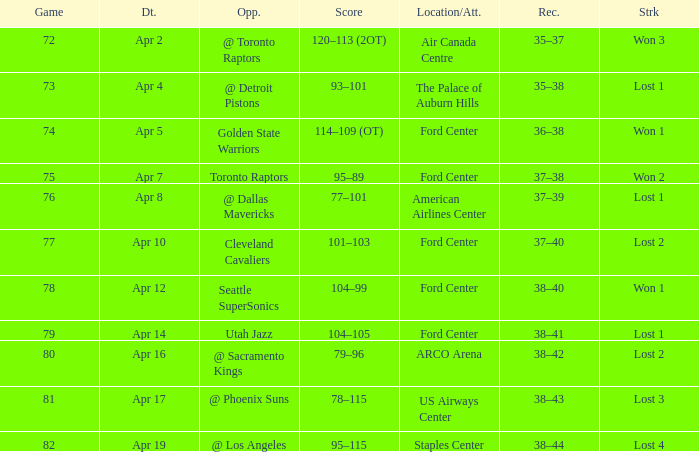Who was the opponent for game 75? Toronto Raptors. 